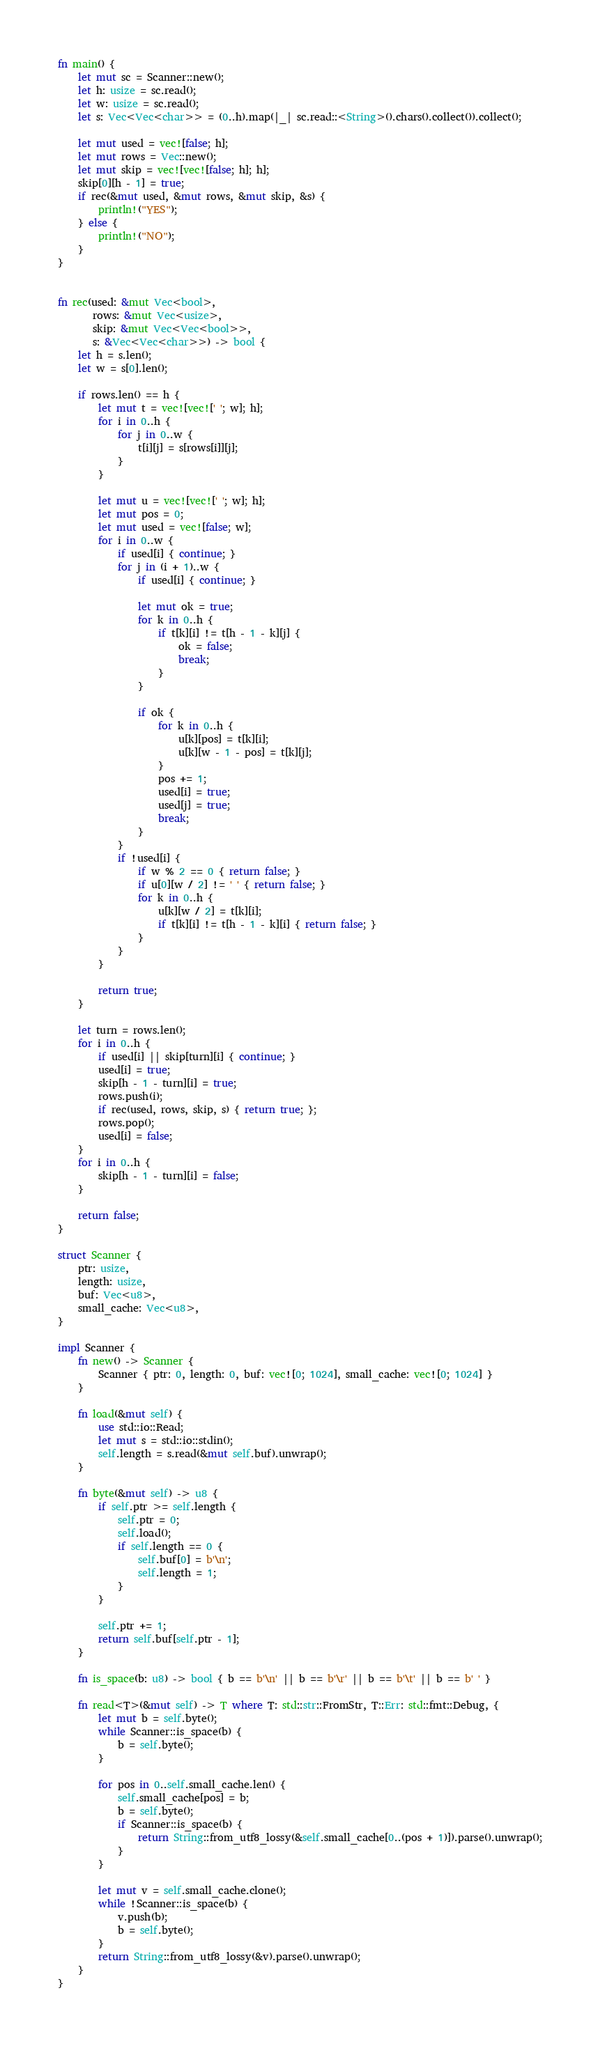Convert code to text. <code><loc_0><loc_0><loc_500><loc_500><_Rust_>fn main() {
    let mut sc = Scanner::new();
    let h: usize = sc.read();
    let w: usize = sc.read();
    let s: Vec<Vec<char>> = (0..h).map(|_| sc.read::<String>().chars().collect()).collect();

    let mut used = vec![false; h];
    let mut rows = Vec::new();
    let mut skip = vec![vec![false; h]; h];
    skip[0][h - 1] = true;
    if rec(&mut used, &mut rows, &mut skip, &s) {
        println!("YES");
    } else {
        println!("NO");
    }
}


fn rec(used: &mut Vec<bool>,
       rows: &mut Vec<usize>,
       skip: &mut Vec<Vec<bool>>,
       s: &Vec<Vec<char>>) -> bool {
    let h = s.len();
    let w = s[0].len();

    if rows.len() == h {
        let mut t = vec![vec![' '; w]; h];
        for i in 0..h {
            for j in 0..w {
                t[i][j] = s[rows[i]][j];
            }
        }

        let mut u = vec![vec![' '; w]; h];
        let mut pos = 0;
        let mut used = vec![false; w];
        for i in 0..w {
            if used[i] { continue; }
            for j in (i + 1)..w {
                if used[i] { continue; }

                let mut ok = true;
                for k in 0..h {
                    if t[k][i] != t[h - 1 - k][j] {
                        ok = false;
                        break;
                    }
                }

                if ok {
                    for k in 0..h {
                        u[k][pos] = t[k][i];
                        u[k][w - 1 - pos] = t[k][j];
                    }
                    pos += 1;
                    used[i] = true;
                    used[j] = true;
                    break;
                }
            }
            if !used[i] {
                if w % 2 == 0 { return false; }
                if u[0][w / 2] != ' ' { return false; }
                for k in 0..h {
                    u[k][w / 2] = t[k][i];
                    if t[k][i] != t[h - 1 - k][i] { return false; }
                }
            }
        }

        return true;
    }

    let turn = rows.len();
    for i in 0..h {
        if used[i] || skip[turn][i] { continue; }
        used[i] = true;
        skip[h - 1 - turn][i] = true;
        rows.push(i);
        if rec(used, rows, skip, s) { return true; };
        rows.pop();
        used[i] = false;
    }
    for i in 0..h {
        skip[h - 1 - turn][i] = false;
    }

    return false;
}

struct Scanner {
    ptr: usize,
    length: usize,
    buf: Vec<u8>,
    small_cache: Vec<u8>,
}

impl Scanner {
    fn new() -> Scanner {
        Scanner { ptr: 0, length: 0, buf: vec![0; 1024], small_cache: vec![0; 1024] }
    }

    fn load(&mut self) {
        use std::io::Read;
        let mut s = std::io::stdin();
        self.length = s.read(&mut self.buf).unwrap();
    }

    fn byte(&mut self) -> u8 {
        if self.ptr >= self.length {
            self.ptr = 0;
            self.load();
            if self.length == 0 {
                self.buf[0] = b'\n';
                self.length = 1;
            }
        }

        self.ptr += 1;
        return self.buf[self.ptr - 1];
    }

    fn is_space(b: u8) -> bool { b == b'\n' || b == b'\r' || b == b'\t' || b == b' ' }

    fn read<T>(&mut self) -> T where T: std::str::FromStr, T::Err: std::fmt::Debug, {
        let mut b = self.byte();
        while Scanner::is_space(b) {
            b = self.byte();
        }

        for pos in 0..self.small_cache.len() {
            self.small_cache[pos] = b;
            b = self.byte();
            if Scanner::is_space(b) {
                return String::from_utf8_lossy(&self.small_cache[0..(pos + 1)]).parse().unwrap();
            }
        }

        let mut v = self.small_cache.clone();
        while !Scanner::is_space(b) {
            v.push(b);
            b = self.byte();
        }
        return String::from_utf8_lossy(&v).parse().unwrap();
    }
}

</code> 